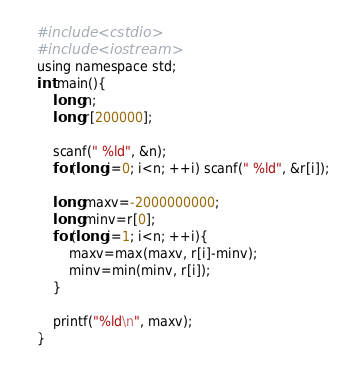<code> <loc_0><loc_0><loc_500><loc_500><_C_>#include <cstdio>
#include <iostream>
using namespace std;
int main(){
    long n;
    long r[200000];
    
    scanf(" %ld", &n);
    for(long i=0; i<n; ++i) scanf(" %ld", &r[i]);
    
    long maxv=-2000000000;
    long minv=r[0];
    for(long i=1; i<n; ++i){
        maxv=max(maxv, r[i]-minv);
        minv=min(minv, r[i]);   
    }
   
    printf("%ld\n", maxv);
}
</code> 